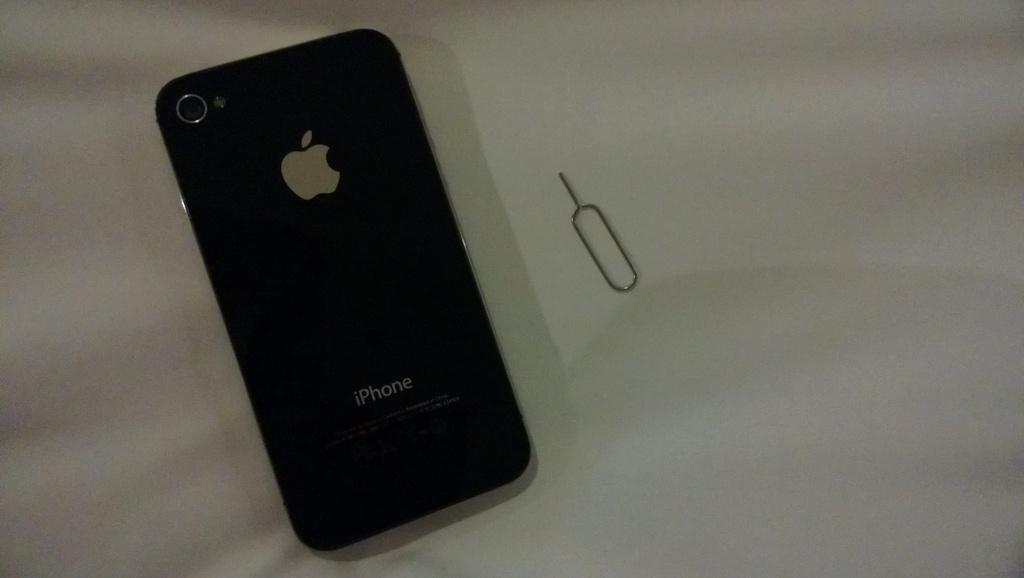<image>
Create a compact narrative representing the image presented. The Back of an Apple Iphone with the Apple Logo and a Camera. 